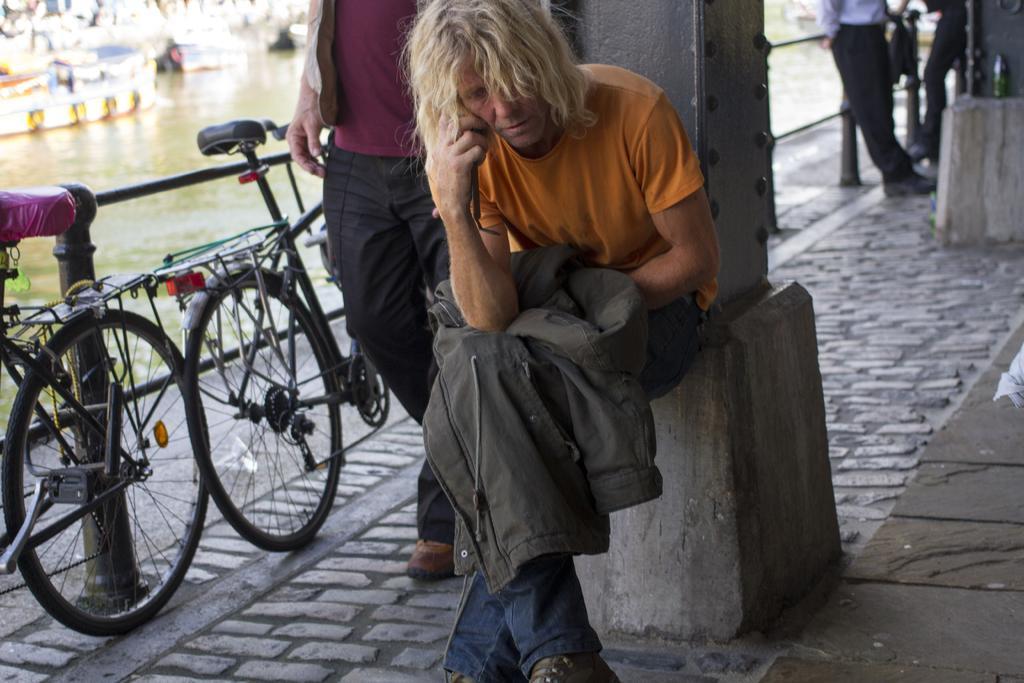Please provide a concise description of this image. In front of the image there is a person sitting on the pillar. Beside him there is another person walking. Behind him there is a bottle on the pillar. There are a few other people standing. On the left side of the image there are cycles. There is a railing. There are boats in the water. 